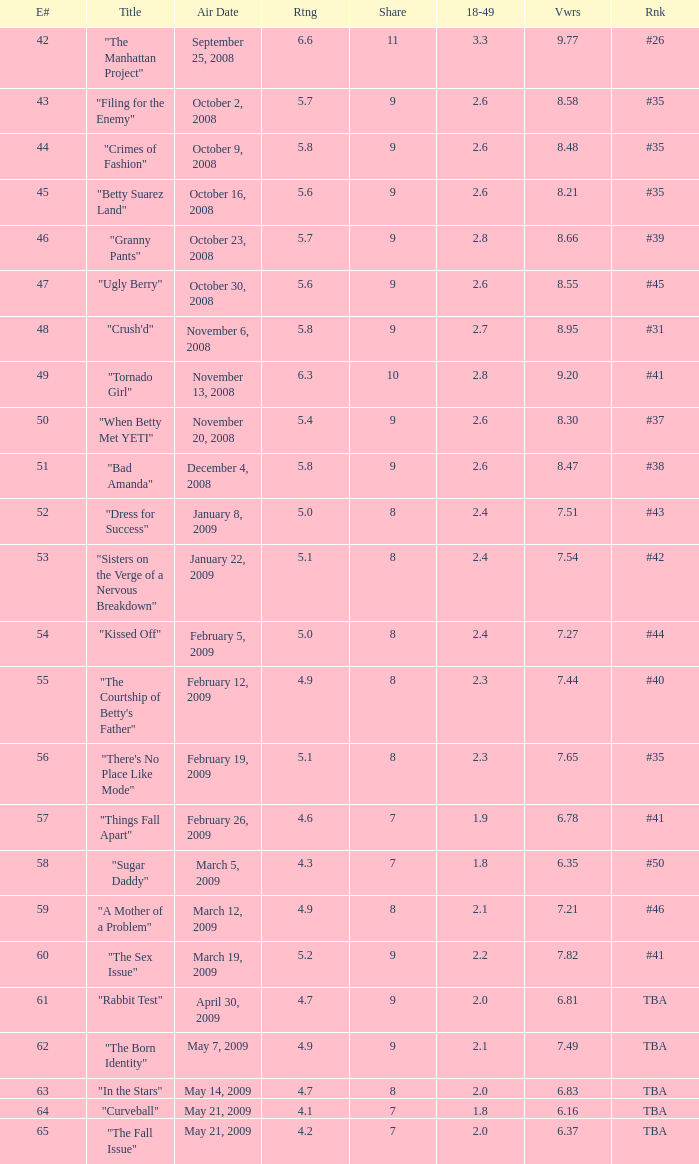What is the average Episode # with a share of 9, and #35 is rank and less than 8.21 viewers? None. 